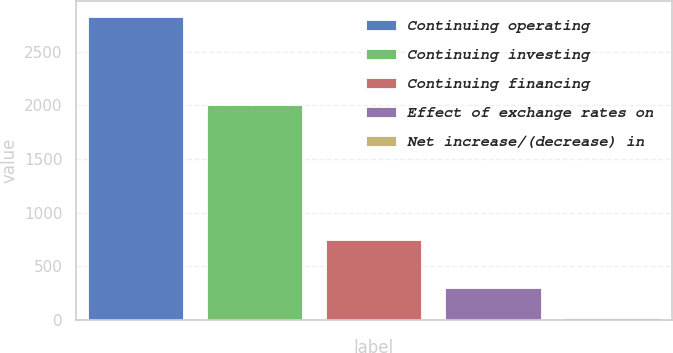Convert chart. <chart><loc_0><loc_0><loc_500><loc_500><bar_chart><fcel>Continuing operating<fcel>Continuing investing<fcel>Continuing financing<fcel>Effect of exchange rates on<fcel>Net increase/(decrease) in<nl><fcel>2827<fcel>2008<fcel>744<fcel>297.1<fcel>16<nl></chart> 